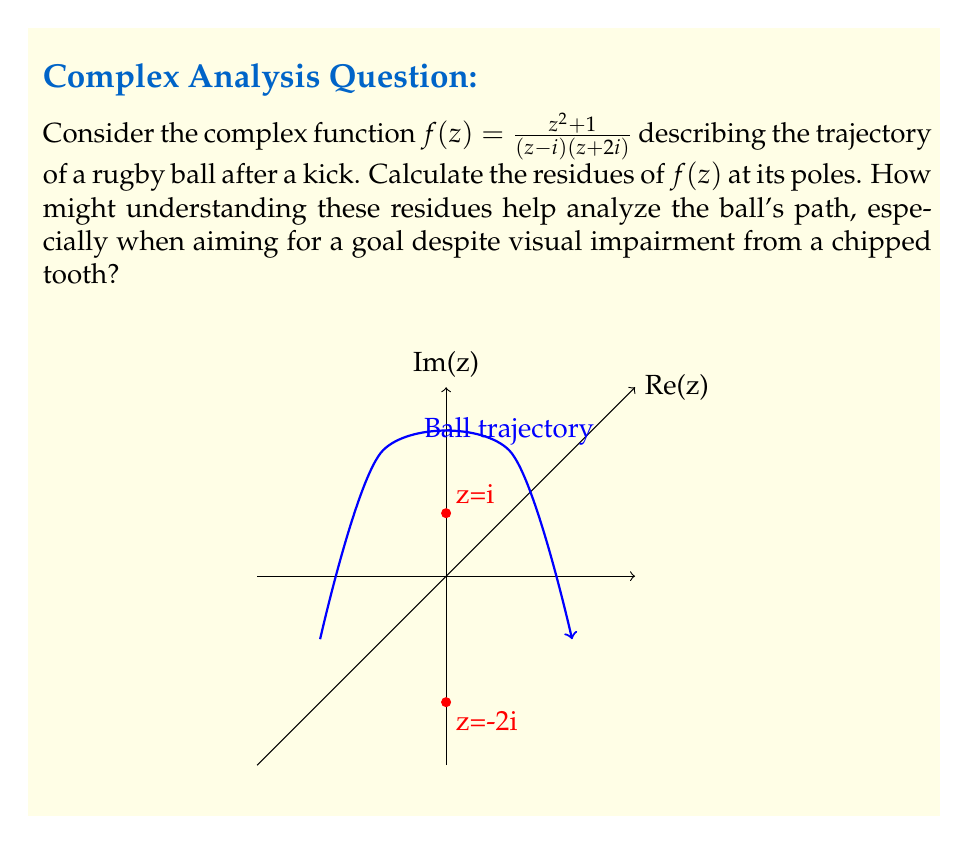Could you help me with this problem? To calculate the residues of $f(z) = \frac{z^2 + 1}{(z-i)(z+2i)}$ at its poles, we follow these steps:

1) First, identify the poles of $f(z)$. They are at $z=i$ and $z=-2i$.

2) For the residue at $z=i$:
   $$\text{Res}(f,i) = \lim_{z \to i} (z-i)f(z) = \lim_{z \to i} \frac{z^2 + 1}{(z+2i)}$$
   $$= \frac{i^2 + 1}{(i+2i)} = \frac{-1 + 1}{3i} = 0$$

3) For the residue at $z=-2i$:
   $$\text{Res}(f,-2i) = \lim_{z \to -2i} (z+2i)f(z) = \lim_{z \to -2i} \frac{z^2 + 1}{(z-i)}$$
   $$= \frac{(-2i)^2 + 1}{(-2i-i)} = \frac{-4 + 1}{-3i} = \frac{1}{i} = -i$$

Understanding these residues can help analyze the ball's path in several ways:
1) The residue at $z=i$ being 0 suggests the function behaves smoothly near this point, which could indicate a stable part of the trajectory.
2) The non-zero residue at $z=-2i$ indicates a more complex behavior near this point, possibly representing a turning point or change in the ball's direction.
3) The imaginary nature of the non-zero residue (-i) might relate to the vertical component of the ball's motion.

For a player with visual impairment from a chipped tooth, understanding these mathematical properties could provide additional insights into the ball's behavior, complementing their potentially compromised visual perception.
Answer: $\text{Res}(f,i) = 0$, $\text{Res}(f,-2i) = -i$ 